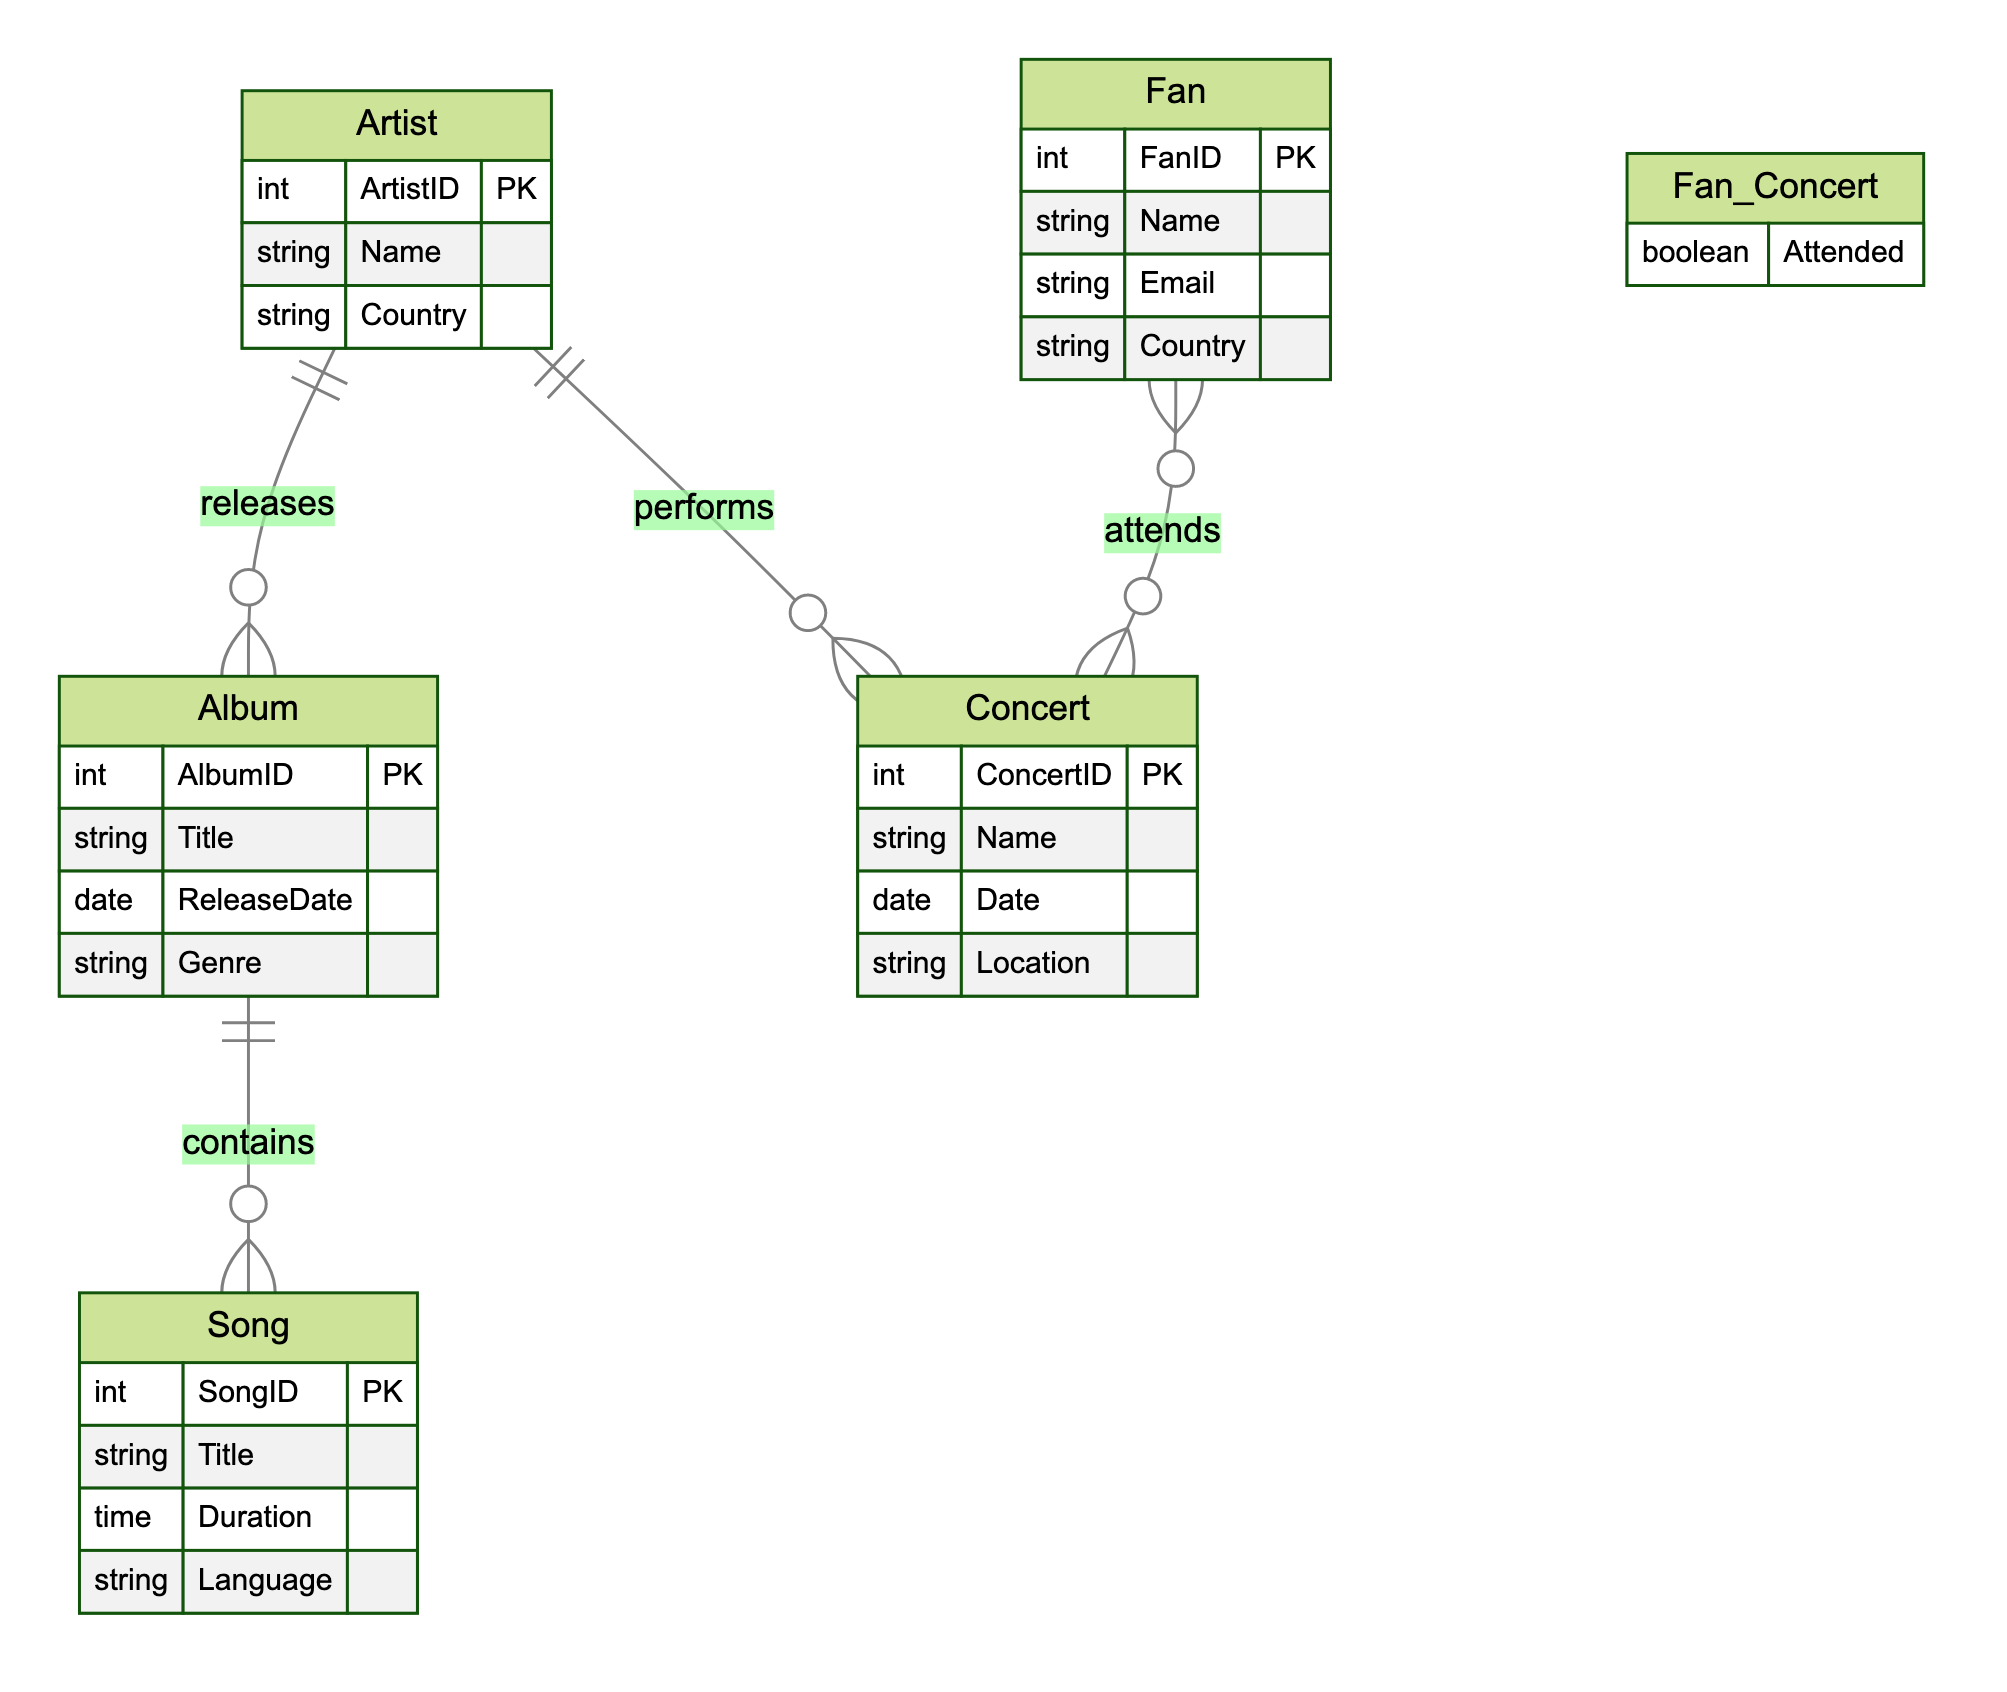What is the primary key of the Album entity? The primary key for the Album entity is AlbumID, which uniquely identifies each album in the database.
Answer: AlbumID How many attributes are there in the Song entity? The Song entity contains four attributes: SongID, Title, Duration, and Language.
Answer: 4 Which entities are connected by the Album_Artist relationship? The Album_Artist relationship connects the Album and Artist entities, indicating that an artist releases albums.
Answer: Album and Artist What boolean attribute is associated with the Fan_Concert relationship? The boolean attribute associated with the Fan_Concert relationship is Attended, indicating whether the fan attended the concert or not.
Answer: Attended What is the genre of the Album entity? The genre is an attribute of the Album entity, but it is not a singular answer as it may vary across different albums.
Answer: Genre How many total entities are present in the diagram? The diagram includes five entities: Artist, Album, Song, Concert, and Fan.
Answer: 5 Which entity has a relationship with the Concert entity? The entities that have a relationship with the Concert entity are Artist and Fan, indicating that artists perform at concerts and fans attend them.
Answer: Artist and Fan What type of relationship exists between Song and Album? The relationship between Song and Album is a "contains" relationship, indicating that albums contain songs.
Answer: contains What is the primary key of the Fan entity? The primary key of the Fan entity is FanID, which uniquely identifies each fan in the database.
Answer: FanID 